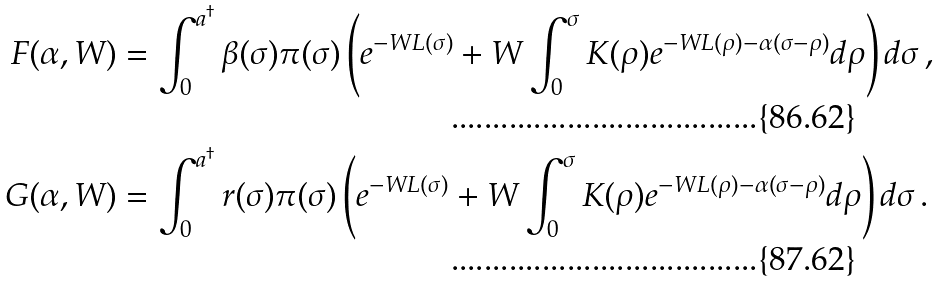Convert formula to latex. <formula><loc_0><loc_0><loc_500><loc_500>F ( \alpha , W ) & = \int _ { 0 } ^ { a ^ { \dagger } } \beta ( \sigma ) \pi ( \sigma ) \left ( e ^ { - W L ( \sigma ) } + W \int _ { 0 } ^ { \sigma } K ( \rho ) e ^ { - W L ( \rho ) - \alpha ( \sigma - \rho ) } d \rho \right ) d \sigma \, , \\ G ( \alpha , W ) & = \int _ { 0 } ^ { a ^ { \dagger } } r ( \sigma ) \pi ( \sigma ) \left ( e ^ { - W L ( \sigma ) } + W \int _ { 0 } ^ { \sigma } K ( \rho ) e ^ { - W L ( \rho ) - \alpha ( \sigma - \rho ) } d \rho \right ) d \sigma \, .</formula> 